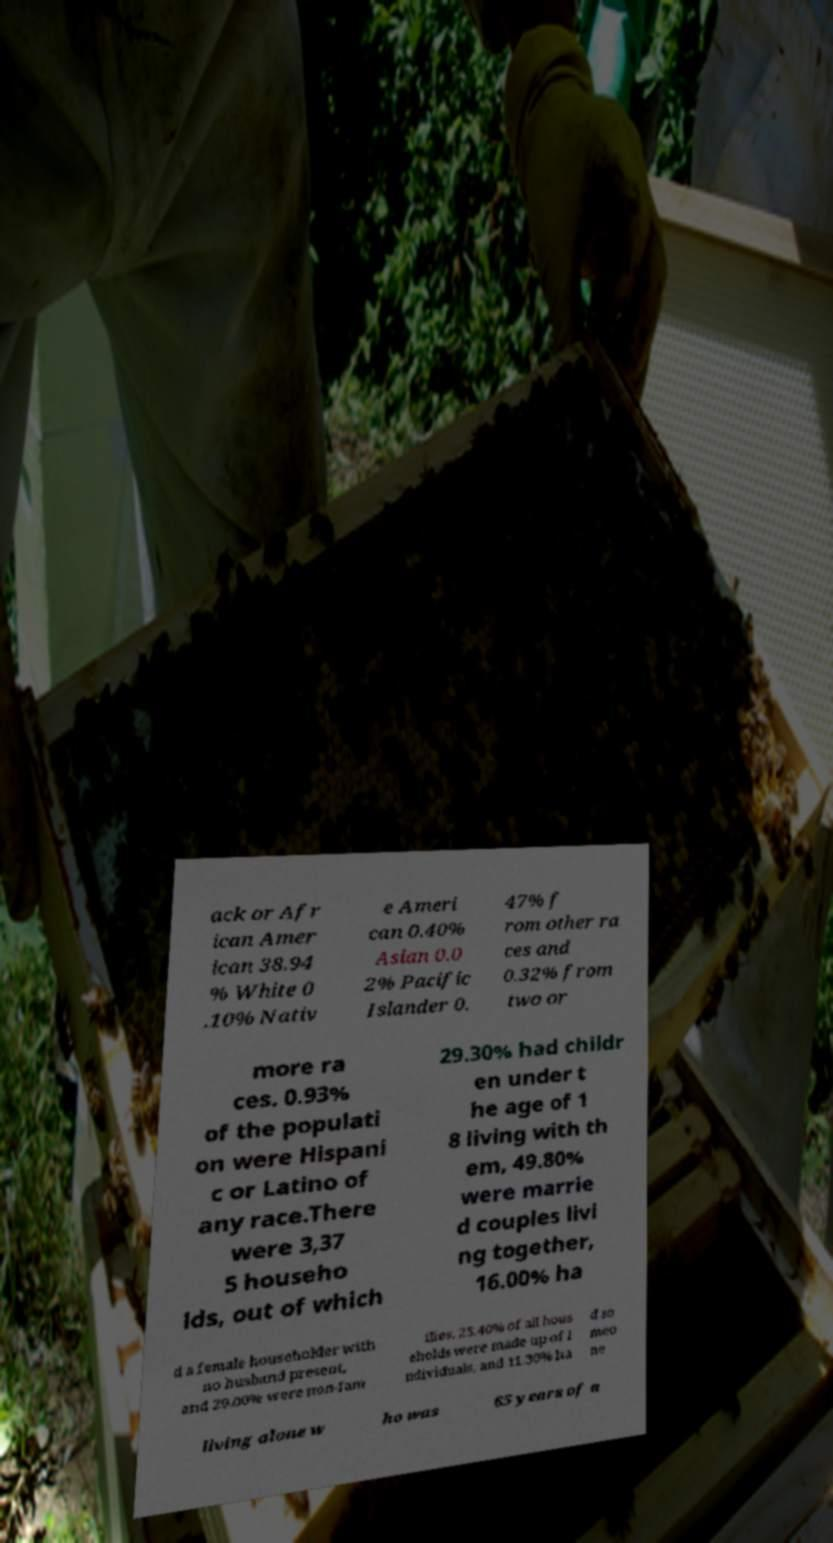Could you extract and type out the text from this image? ack or Afr ican Amer ican 38.94 % White 0 .10% Nativ e Ameri can 0.40% Asian 0.0 2% Pacific Islander 0. 47% f rom other ra ces and 0.32% from two or more ra ces. 0.93% of the populati on were Hispani c or Latino of any race.There were 3,37 5 househo lds, out of which 29.30% had childr en under t he age of 1 8 living with th em, 49.80% were marrie d couples livi ng together, 16.00% ha d a female householder with no husband present, and 29.00% were non-fam ilies. 25.40% of all hous eholds were made up of i ndividuals, and 11.30% ha d so meo ne living alone w ho was 65 years of a 